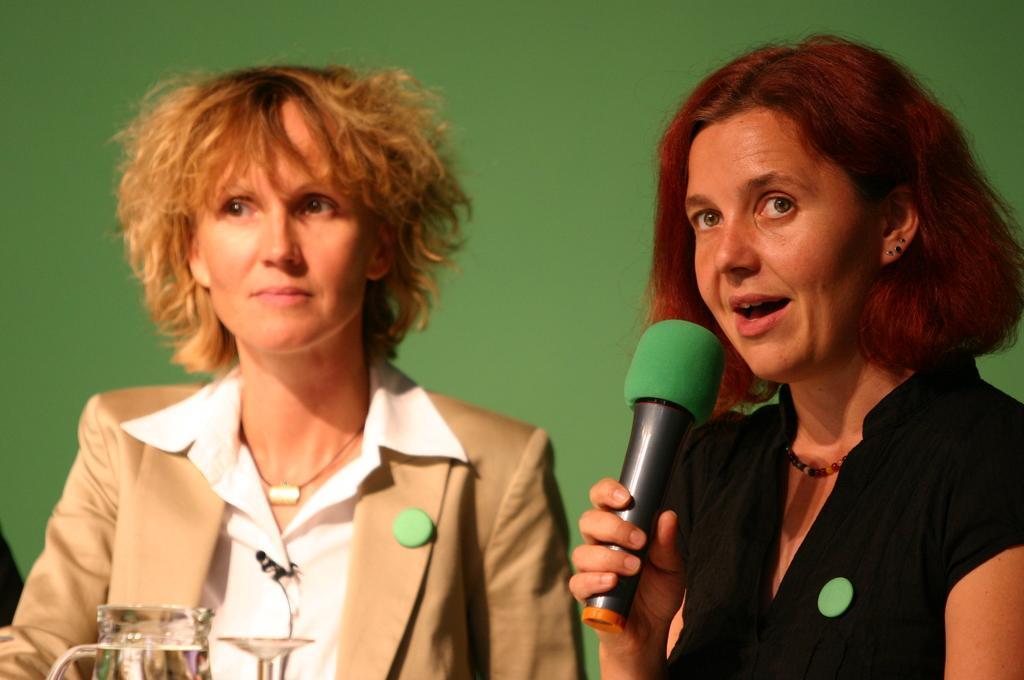Can you describe this image briefly? These two persons sitting and this person holding microphone. We can see jar,glass. On the background we can see wall. 